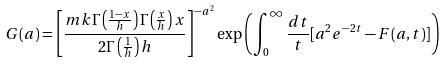Convert formula to latex. <formula><loc_0><loc_0><loc_500><loc_500>G ( a ) = \left [ \frac { m k \Gamma \left ( \frac { 1 - x } { h } \right ) \Gamma \left ( \frac { x } { h } \right ) x } { 2 \Gamma \left ( \frac { 1 } { h } \right ) h } \right ] ^ { - a ^ { 2 } } \exp \left ( \int _ { 0 } ^ { \infty } \frac { d t } { t } [ a ^ { 2 } e ^ { - 2 t } - F ( a , t ) ] \right )</formula> 